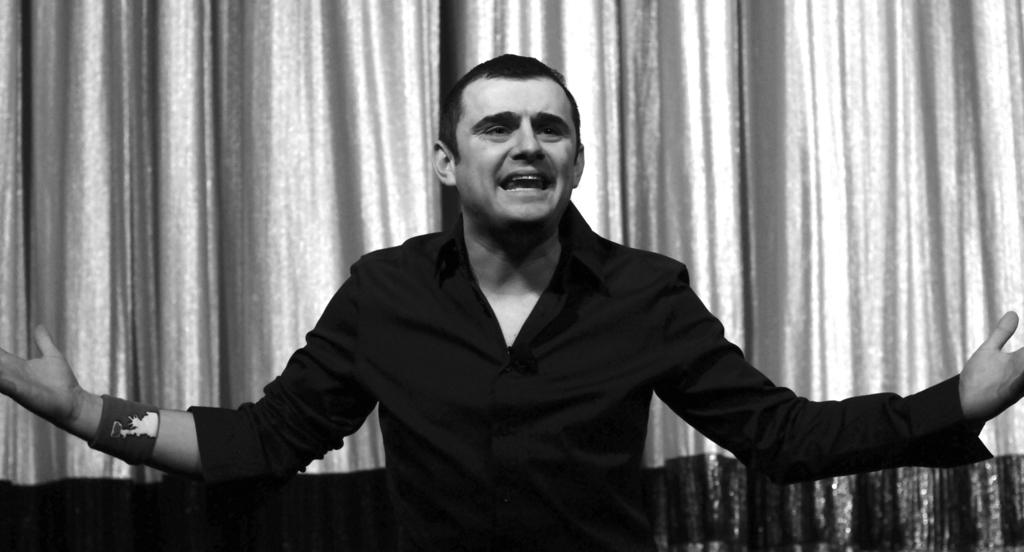What is the main subject of the image? There is a man standing in the image. What is the man wearing? The man is wearing a black dress. What can be seen in the background of the image? There is a curtain in the background of the image. What type of mine can be seen in the image? There is no mine present in the image; it features a man standing in a black dress with a curtain in the background. What is the texture of the man's finger in the image? There is no information about the texture of the man's finger in the image, as it is not mentioned in the provided facts. 